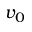<formula> <loc_0><loc_0><loc_500><loc_500>v _ { 0 }</formula> 